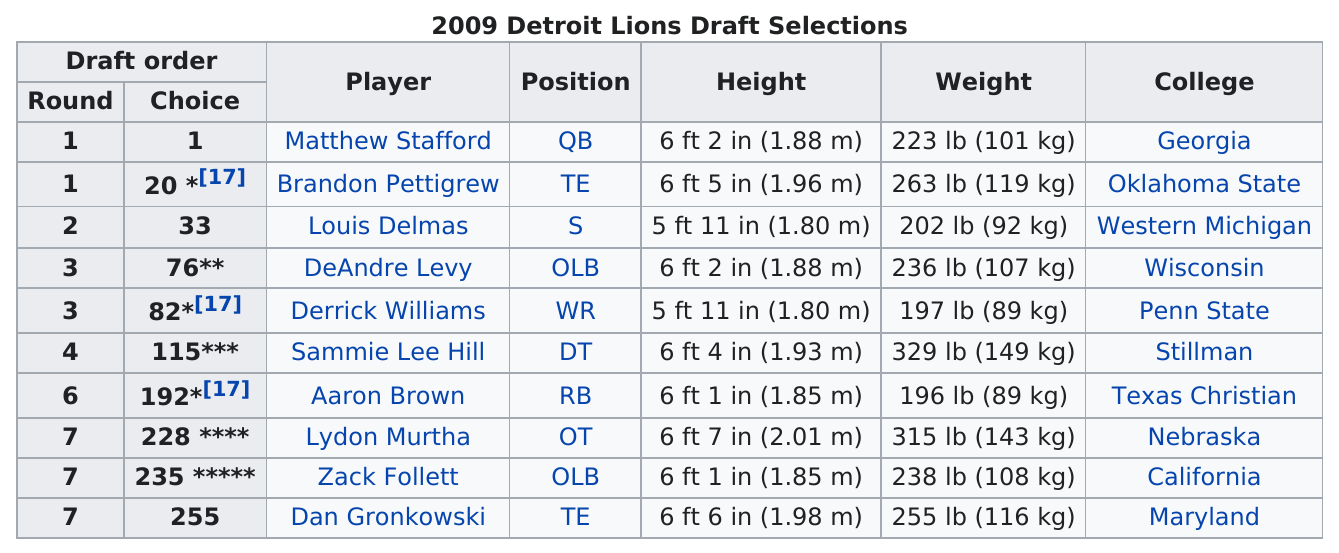Outline some significant characteristics in this image. The last player to be drafted was Dan Gronkowski. The number of players drafted for the position is two. Of the players, how many weigh under 200 pounds? Louis Delmas and Derrick Williams are the only players who are under six feet tall. Brandon Pettigrew weighs more than 250 pounds. 